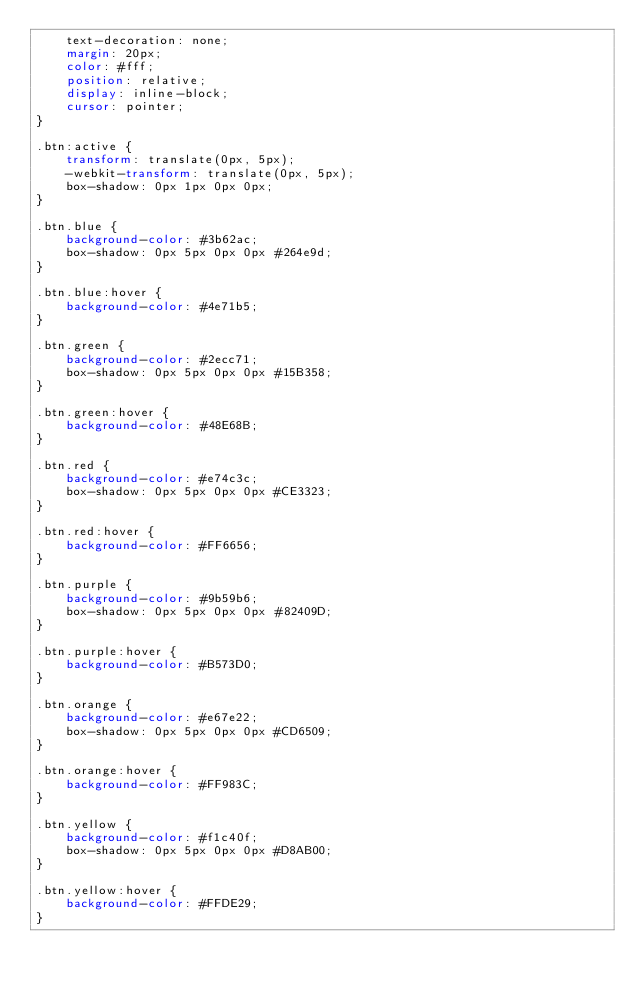<code> <loc_0><loc_0><loc_500><loc_500><_CSS_>    text-decoration: none;
    margin: 20px;
    color: #fff;
    position: relative;
    display: inline-block;
    cursor: pointer;
}

.btn:active {
    transform: translate(0px, 5px);
    -webkit-transform: translate(0px, 5px);
    box-shadow: 0px 1px 0px 0px;
}

.btn.blue {
    background-color: #3b62ac;
    box-shadow: 0px 5px 0px 0px #264e9d;
}

.btn.blue:hover {
    background-color: #4e71b5;
}

.btn.green {
    background-color: #2ecc71;
    box-shadow: 0px 5px 0px 0px #15B358;
}

.btn.green:hover {
    background-color: #48E68B;
}

.btn.red {
    background-color: #e74c3c;
    box-shadow: 0px 5px 0px 0px #CE3323;
}

.btn.red:hover {
    background-color: #FF6656;
}

.btn.purple {
    background-color: #9b59b6;
    box-shadow: 0px 5px 0px 0px #82409D;
}

.btn.purple:hover {
    background-color: #B573D0;
}

.btn.orange {
    background-color: #e67e22;
    box-shadow: 0px 5px 0px 0px #CD6509;
}

.btn.orange:hover {
    background-color: #FF983C;
}

.btn.yellow {
    background-color: #f1c40f;
    box-shadow: 0px 5px 0px 0px #D8AB00;
}

.btn.yellow:hover {
    background-color: #FFDE29;
}
</code> 